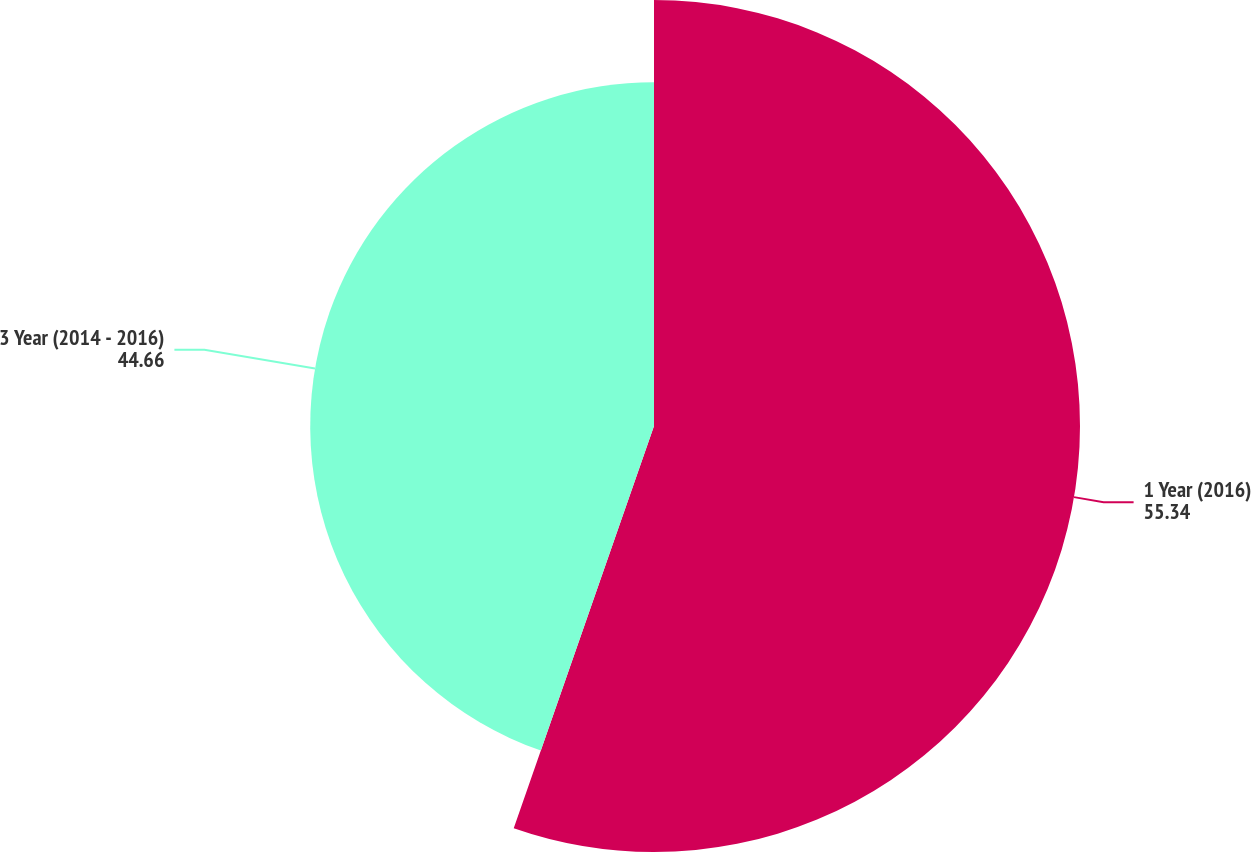Convert chart. <chart><loc_0><loc_0><loc_500><loc_500><pie_chart><fcel>1 Year (2016)<fcel>3 Year (2014 - 2016)<nl><fcel>55.34%<fcel>44.66%<nl></chart> 